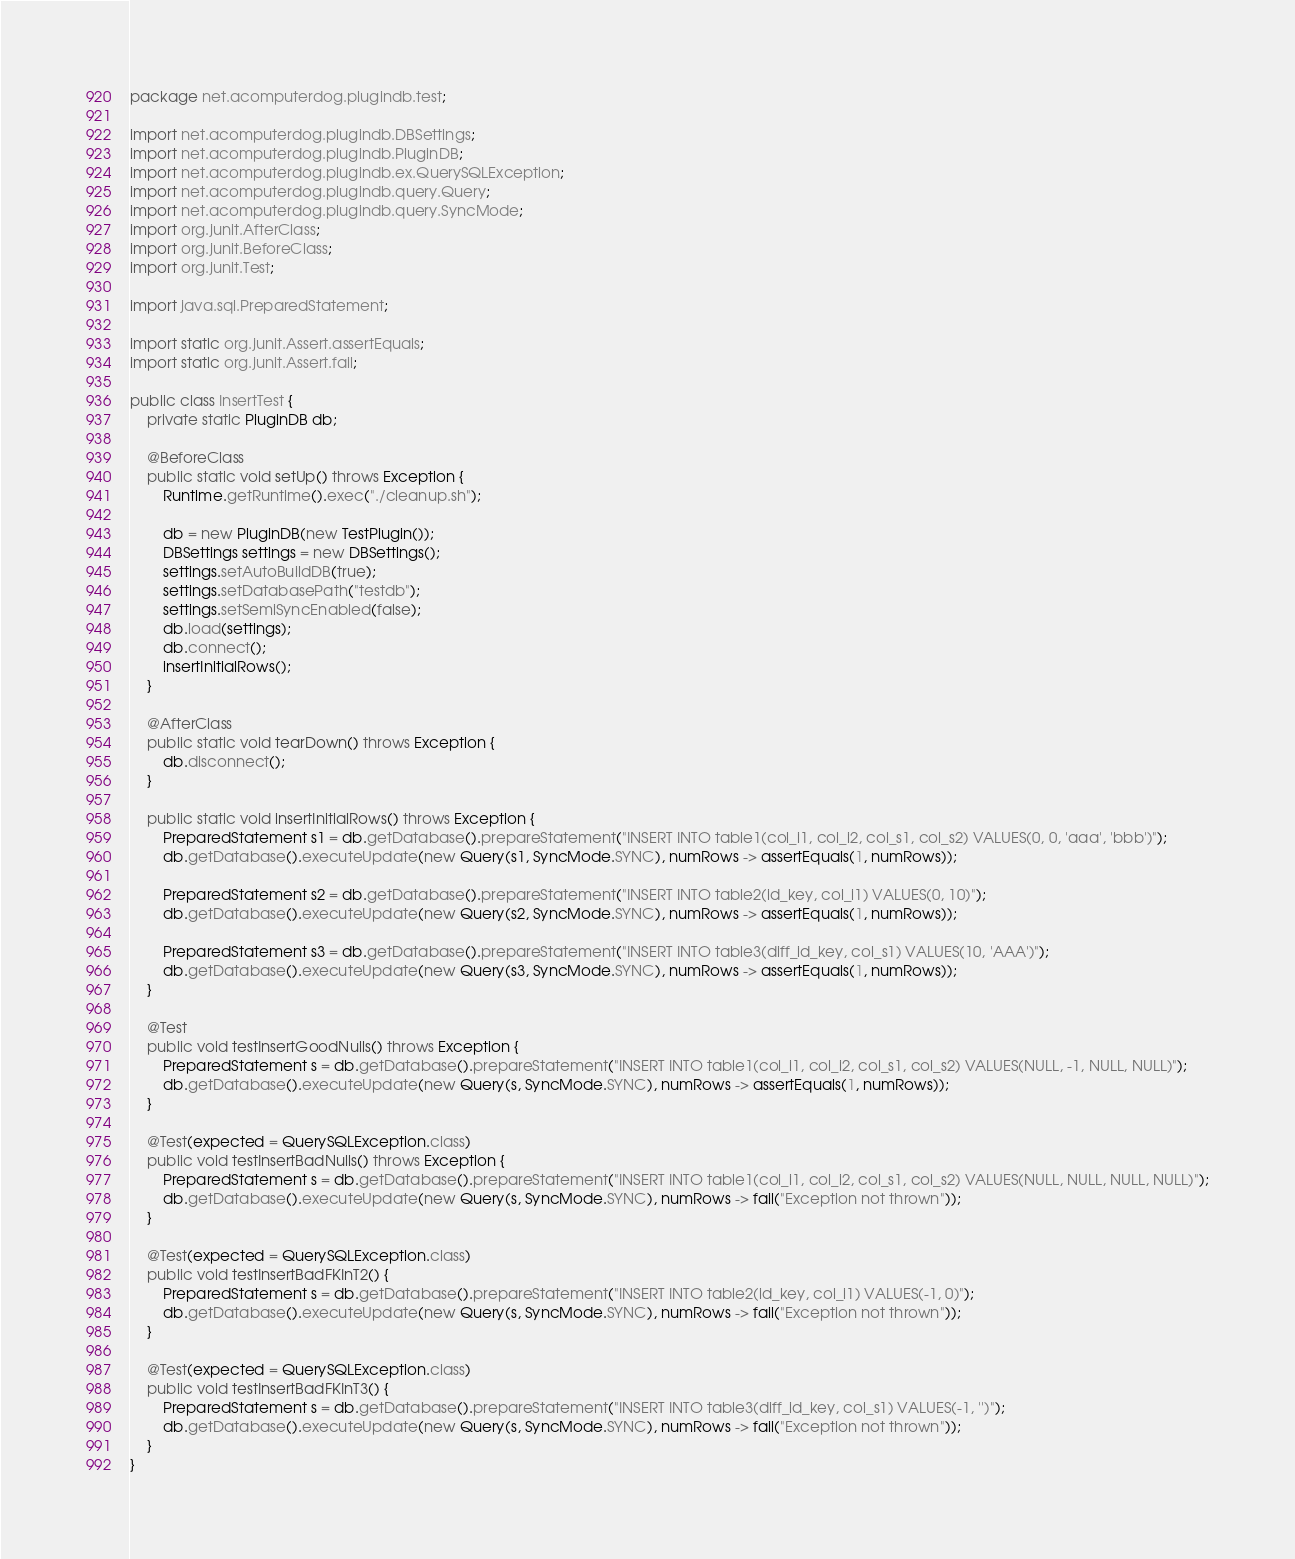<code> <loc_0><loc_0><loc_500><loc_500><_Java_>package net.acomputerdog.plugindb.test;

import net.acomputerdog.plugindb.DBSettings;
import net.acomputerdog.plugindb.PluginDB;
import net.acomputerdog.plugindb.ex.QuerySQLException;
import net.acomputerdog.plugindb.query.Query;
import net.acomputerdog.plugindb.query.SyncMode;
import org.junit.AfterClass;
import org.junit.BeforeClass;
import org.junit.Test;

import java.sql.PreparedStatement;

import static org.junit.Assert.assertEquals;
import static org.junit.Assert.fail;

public class InsertTest {
    private static PluginDB db;

    @BeforeClass
    public static void setUp() throws Exception {
        Runtime.getRuntime().exec("./cleanup.sh");

        db = new PluginDB(new TestPlugin());
        DBSettings settings = new DBSettings();
        settings.setAutoBuildDB(true);
        settings.setDatabasePath("testdb");
        settings.setSemiSyncEnabled(false);
        db.load(settings);
        db.connect();
        insertInitialRows();
    }

    @AfterClass
    public static void tearDown() throws Exception {
        db.disconnect();
    }

    public static void insertInitialRows() throws Exception {
        PreparedStatement s1 = db.getDatabase().prepareStatement("INSERT INTO table1(col_i1, col_i2, col_s1, col_s2) VALUES(0, 0, 'aaa', 'bbb')");
        db.getDatabase().executeUpdate(new Query(s1, SyncMode.SYNC), numRows -> assertEquals(1, numRows));

        PreparedStatement s2 = db.getDatabase().prepareStatement("INSERT INTO table2(id_key, col_i1) VALUES(0, 10)");
        db.getDatabase().executeUpdate(new Query(s2, SyncMode.SYNC), numRows -> assertEquals(1, numRows));

        PreparedStatement s3 = db.getDatabase().prepareStatement("INSERT INTO table3(diff_id_key, col_s1) VALUES(10, 'AAA')");
        db.getDatabase().executeUpdate(new Query(s3, SyncMode.SYNC), numRows -> assertEquals(1, numRows));
    }

    @Test
    public void testInsertGoodNulls() throws Exception {
        PreparedStatement s = db.getDatabase().prepareStatement("INSERT INTO table1(col_i1, col_i2, col_s1, col_s2) VALUES(NULL, -1, NULL, NULL)");
        db.getDatabase().executeUpdate(new Query(s, SyncMode.SYNC), numRows -> assertEquals(1, numRows));
    }

    @Test(expected = QuerySQLException.class)
    public void testInsertBadNulls() throws Exception {
        PreparedStatement s = db.getDatabase().prepareStatement("INSERT INTO table1(col_i1, col_i2, col_s1, col_s2) VALUES(NULL, NULL, NULL, NULL)");
        db.getDatabase().executeUpdate(new Query(s, SyncMode.SYNC), numRows -> fail("Exception not thrown"));
    }

    @Test(expected = QuerySQLException.class)
    public void testInsertBadFKInT2() {
        PreparedStatement s = db.getDatabase().prepareStatement("INSERT INTO table2(id_key, col_i1) VALUES(-1, 0)");
        db.getDatabase().executeUpdate(new Query(s, SyncMode.SYNC), numRows -> fail("Exception not thrown"));
    }

    @Test(expected = QuerySQLException.class)
    public void testInsertBadFKInT3() {
        PreparedStatement s = db.getDatabase().prepareStatement("INSERT INTO table3(diff_id_key, col_s1) VALUES(-1, '')");
        db.getDatabase().executeUpdate(new Query(s, SyncMode.SYNC), numRows -> fail("Exception not thrown"));
    }
}
</code> 